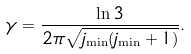<formula> <loc_0><loc_0><loc_500><loc_500>\gamma = \frac { \ln 3 } { 2 \pi \sqrt { j _ { \min } ( j _ { \min } + 1 ) } } .</formula> 